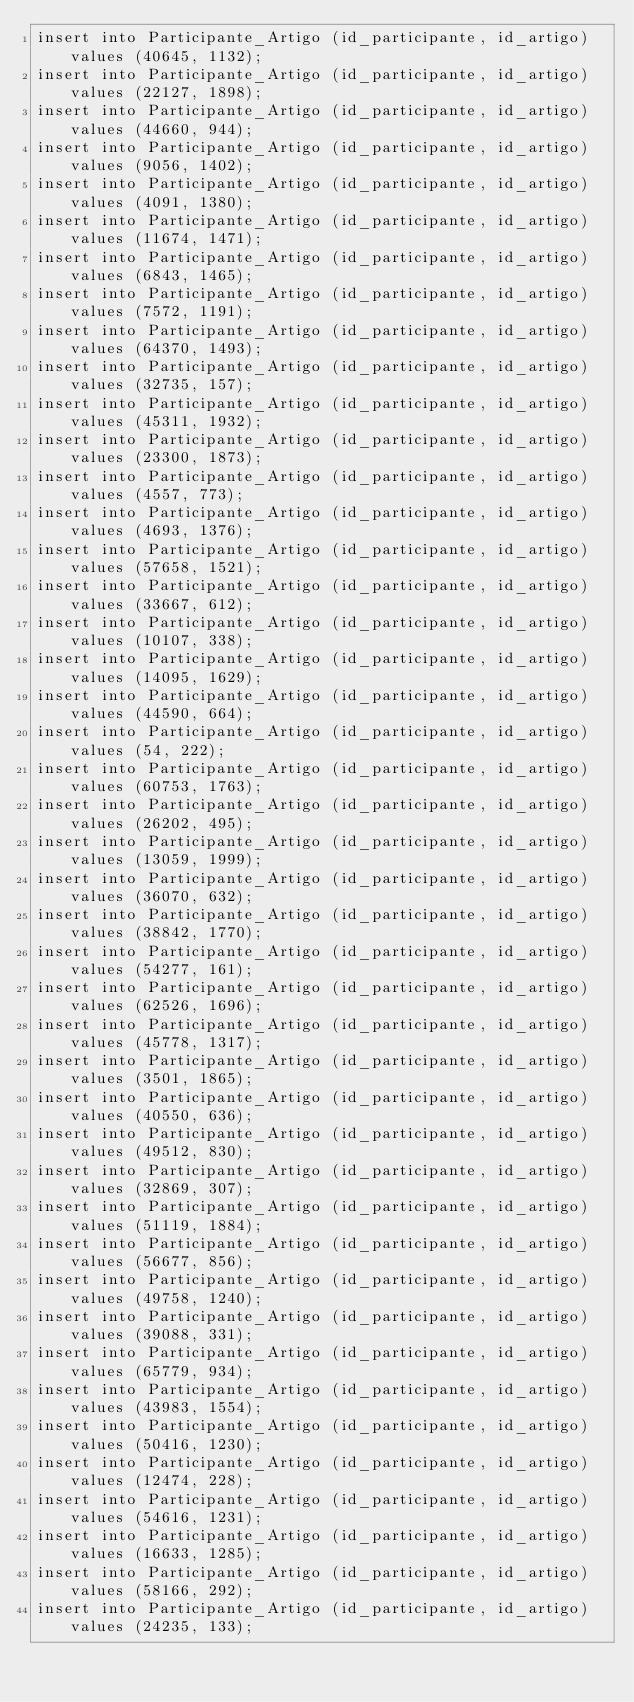<code> <loc_0><loc_0><loc_500><loc_500><_SQL_>insert into Participante_Artigo (id_participante, id_artigo) values (40645, 1132);
insert into Participante_Artigo (id_participante, id_artigo) values (22127, 1898);
insert into Participante_Artigo (id_participante, id_artigo) values (44660, 944);
insert into Participante_Artigo (id_participante, id_artigo) values (9056, 1402);
insert into Participante_Artigo (id_participante, id_artigo) values (4091, 1380);
insert into Participante_Artigo (id_participante, id_artigo) values (11674, 1471);
insert into Participante_Artigo (id_participante, id_artigo) values (6843, 1465);
insert into Participante_Artigo (id_participante, id_artigo) values (7572, 1191);
insert into Participante_Artigo (id_participante, id_artigo) values (64370, 1493);
insert into Participante_Artigo (id_participante, id_artigo) values (32735, 157);
insert into Participante_Artigo (id_participante, id_artigo) values (45311, 1932);
insert into Participante_Artigo (id_participante, id_artigo) values (23300, 1873);
insert into Participante_Artigo (id_participante, id_artigo) values (4557, 773);
insert into Participante_Artigo (id_participante, id_artigo) values (4693, 1376);
insert into Participante_Artigo (id_participante, id_artigo) values (57658, 1521);
insert into Participante_Artigo (id_participante, id_artigo) values (33667, 612);
insert into Participante_Artigo (id_participante, id_artigo) values (10107, 338);
insert into Participante_Artigo (id_participante, id_artigo) values (14095, 1629);
insert into Participante_Artigo (id_participante, id_artigo) values (44590, 664);
insert into Participante_Artigo (id_participante, id_artigo) values (54, 222);
insert into Participante_Artigo (id_participante, id_artigo) values (60753, 1763);
insert into Participante_Artigo (id_participante, id_artigo) values (26202, 495);
insert into Participante_Artigo (id_participante, id_artigo) values (13059, 1999);
insert into Participante_Artigo (id_participante, id_artigo) values (36070, 632);
insert into Participante_Artigo (id_participante, id_artigo) values (38842, 1770);
insert into Participante_Artigo (id_participante, id_artigo) values (54277, 161);
insert into Participante_Artigo (id_participante, id_artigo) values (62526, 1696);
insert into Participante_Artigo (id_participante, id_artigo) values (45778, 1317);
insert into Participante_Artigo (id_participante, id_artigo) values (3501, 1865);
insert into Participante_Artigo (id_participante, id_artigo) values (40550, 636);
insert into Participante_Artigo (id_participante, id_artigo) values (49512, 830);
insert into Participante_Artigo (id_participante, id_artigo) values (32869, 307);
insert into Participante_Artigo (id_participante, id_artigo) values (51119, 1884);
insert into Participante_Artigo (id_participante, id_artigo) values (56677, 856);
insert into Participante_Artigo (id_participante, id_artigo) values (49758, 1240);
insert into Participante_Artigo (id_participante, id_artigo) values (39088, 331);
insert into Participante_Artigo (id_participante, id_artigo) values (65779, 934);
insert into Participante_Artigo (id_participante, id_artigo) values (43983, 1554);
insert into Participante_Artigo (id_participante, id_artigo) values (50416, 1230);
insert into Participante_Artigo (id_participante, id_artigo) values (12474, 228);
insert into Participante_Artigo (id_participante, id_artigo) values (54616, 1231);
insert into Participante_Artigo (id_participante, id_artigo) values (16633, 1285);
insert into Participante_Artigo (id_participante, id_artigo) values (58166, 292);
insert into Participante_Artigo (id_participante, id_artigo) values (24235, 133);</code> 